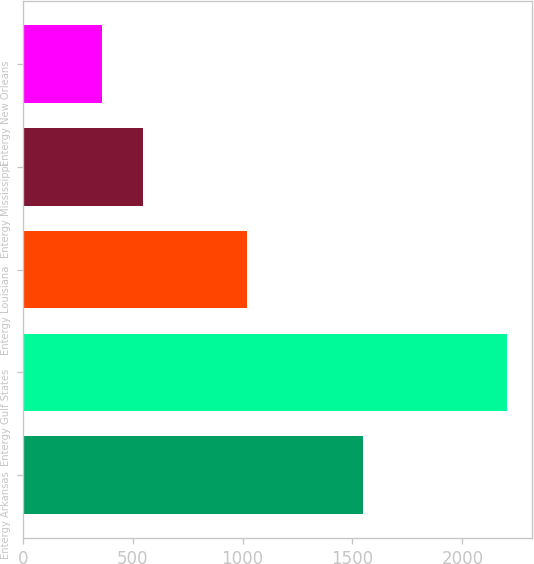Convert chart to OTSL. <chart><loc_0><loc_0><loc_500><loc_500><bar_chart><fcel>Entergy Arkansas<fcel>Entergy Gulf States<fcel>Entergy Louisiana<fcel>Entergy Mississippi<fcel>Entergy New Orleans<nl><fcel>1548<fcel>2205<fcel>1021<fcel>546.3<fcel>362<nl></chart> 